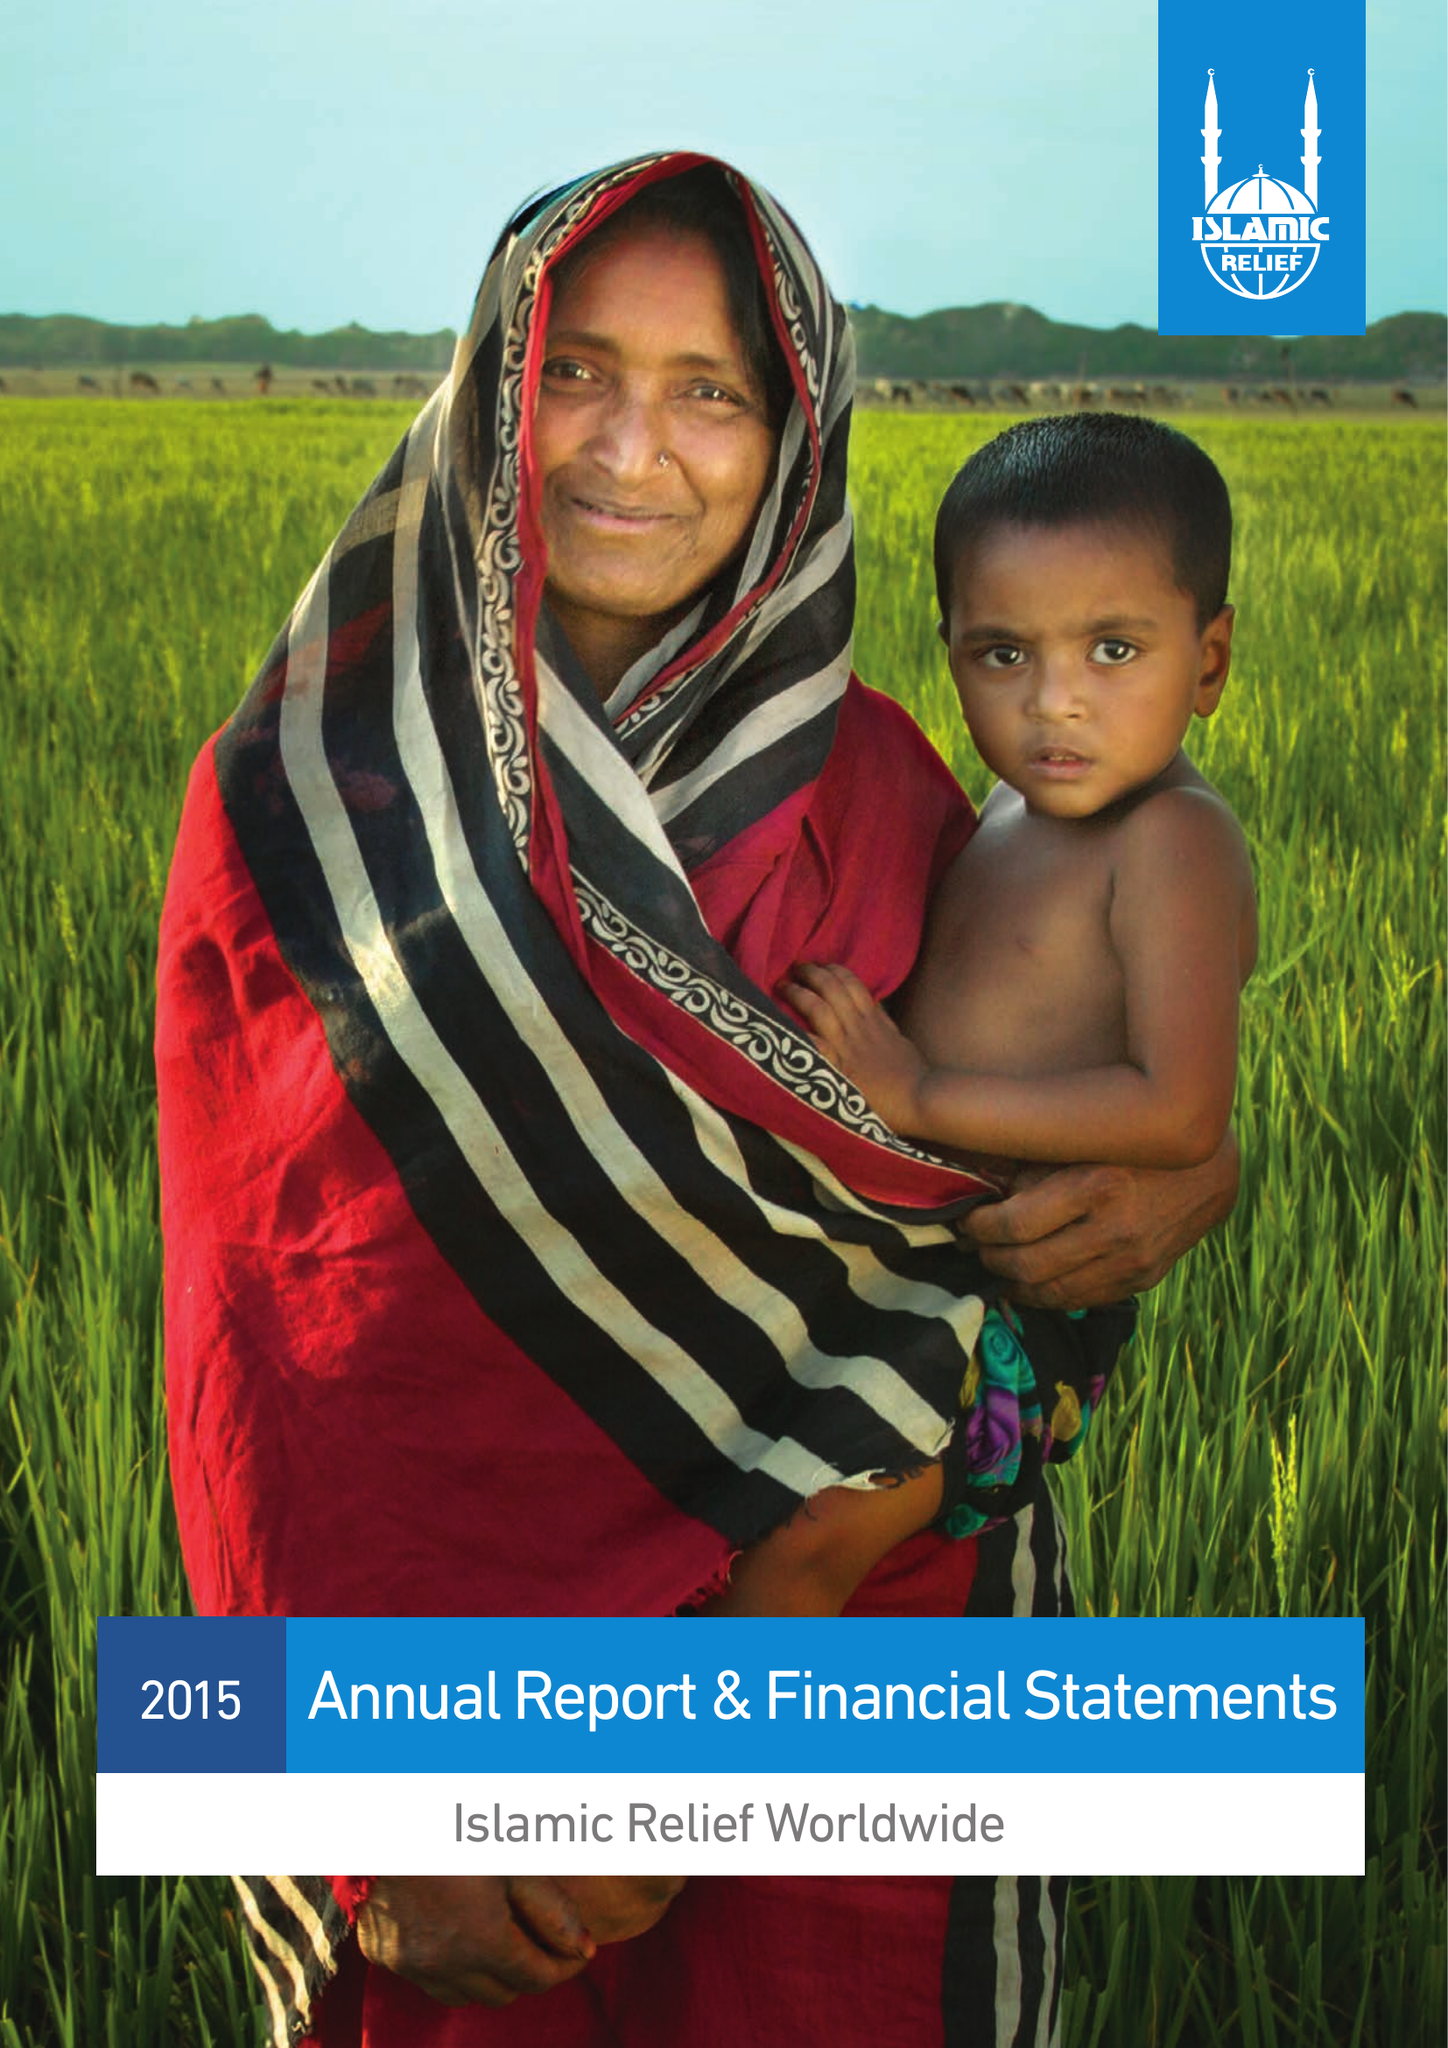What is the value for the spending_annually_in_british_pounds?
Answer the question using a single word or phrase. 112522405.00 